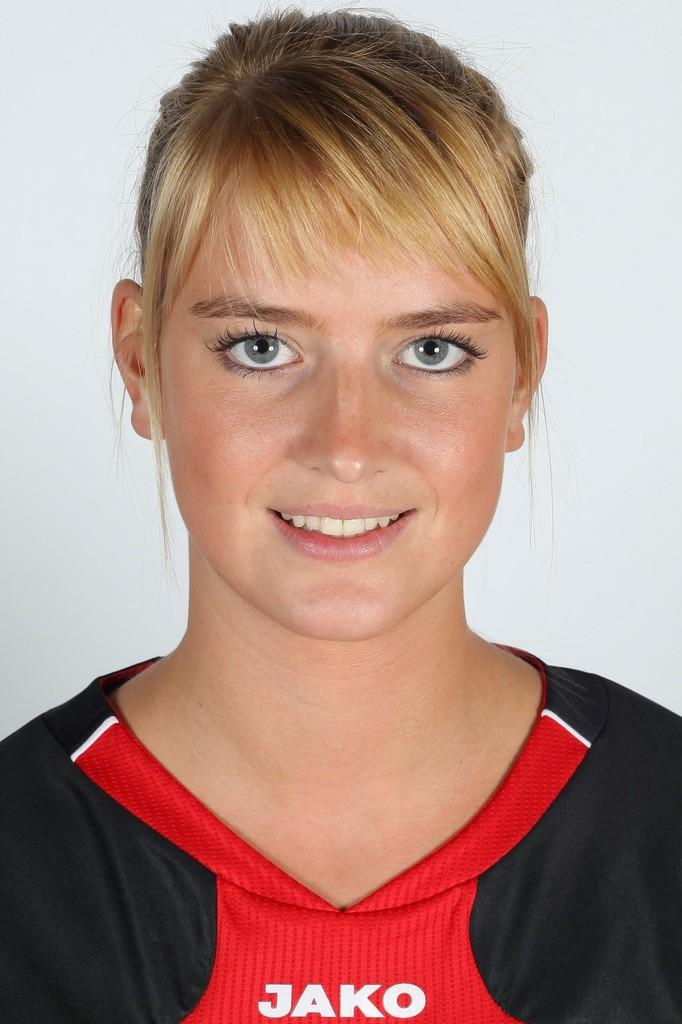<image>
Offer a succinct explanation of the picture presented. A woman's red and black shirt displays the word JAKO on a red section in the front. 